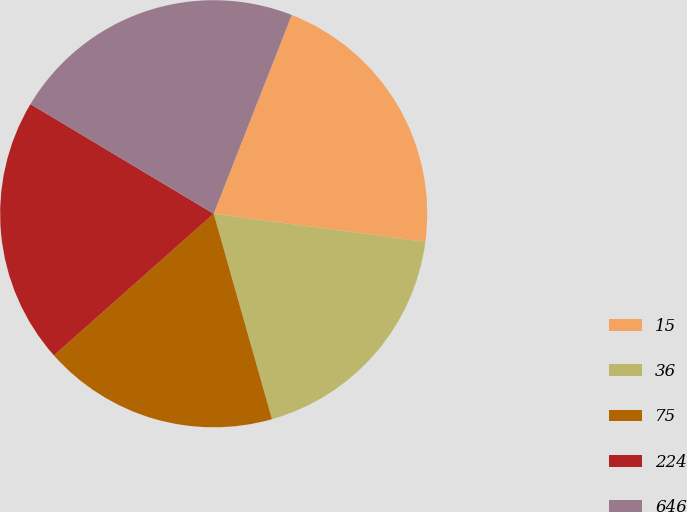Convert chart. <chart><loc_0><loc_0><loc_500><loc_500><pie_chart><fcel>15<fcel>36<fcel>75<fcel>224<fcel>646<nl><fcel>21.14%<fcel>18.5%<fcel>17.85%<fcel>20.13%<fcel>22.37%<nl></chart> 